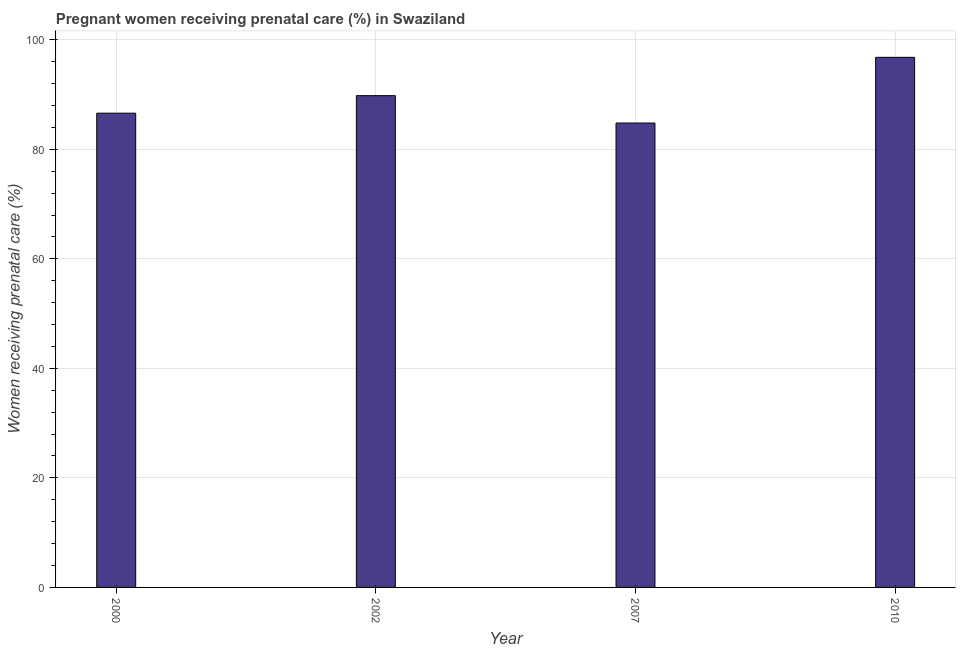Does the graph contain grids?
Give a very brief answer. Yes. What is the title of the graph?
Offer a terse response. Pregnant women receiving prenatal care (%) in Swaziland. What is the label or title of the Y-axis?
Your response must be concise. Women receiving prenatal care (%). What is the percentage of pregnant women receiving prenatal care in 2010?
Your answer should be compact. 96.8. Across all years, what is the maximum percentage of pregnant women receiving prenatal care?
Give a very brief answer. 96.8. Across all years, what is the minimum percentage of pregnant women receiving prenatal care?
Keep it short and to the point. 84.8. In which year was the percentage of pregnant women receiving prenatal care maximum?
Make the answer very short. 2010. In which year was the percentage of pregnant women receiving prenatal care minimum?
Provide a succinct answer. 2007. What is the sum of the percentage of pregnant women receiving prenatal care?
Your answer should be very brief. 358. What is the average percentage of pregnant women receiving prenatal care per year?
Provide a short and direct response. 89.5. What is the median percentage of pregnant women receiving prenatal care?
Provide a short and direct response. 88.2. Is the percentage of pregnant women receiving prenatal care in 2007 less than that in 2010?
Provide a succinct answer. Yes. Is the difference between the percentage of pregnant women receiving prenatal care in 2000 and 2010 greater than the difference between any two years?
Your response must be concise. No. What is the difference between the highest and the second highest percentage of pregnant women receiving prenatal care?
Provide a short and direct response. 7. Is the sum of the percentage of pregnant women receiving prenatal care in 2000 and 2007 greater than the maximum percentage of pregnant women receiving prenatal care across all years?
Offer a terse response. Yes. In how many years, is the percentage of pregnant women receiving prenatal care greater than the average percentage of pregnant women receiving prenatal care taken over all years?
Ensure brevity in your answer.  2. How many bars are there?
Provide a short and direct response. 4. Are all the bars in the graph horizontal?
Keep it short and to the point. No. How many years are there in the graph?
Provide a short and direct response. 4. What is the Women receiving prenatal care (%) of 2000?
Offer a very short reply. 86.6. What is the Women receiving prenatal care (%) in 2002?
Make the answer very short. 89.8. What is the Women receiving prenatal care (%) of 2007?
Ensure brevity in your answer.  84.8. What is the Women receiving prenatal care (%) in 2010?
Make the answer very short. 96.8. What is the difference between the Women receiving prenatal care (%) in 2000 and 2007?
Your answer should be very brief. 1.8. What is the difference between the Women receiving prenatal care (%) in 2007 and 2010?
Provide a succinct answer. -12. What is the ratio of the Women receiving prenatal care (%) in 2000 to that in 2007?
Your answer should be compact. 1.02. What is the ratio of the Women receiving prenatal care (%) in 2000 to that in 2010?
Offer a very short reply. 0.9. What is the ratio of the Women receiving prenatal care (%) in 2002 to that in 2007?
Your answer should be very brief. 1.06. What is the ratio of the Women receiving prenatal care (%) in 2002 to that in 2010?
Your response must be concise. 0.93. What is the ratio of the Women receiving prenatal care (%) in 2007 to that in 2010?
Your answer should be compact. 0.88. 